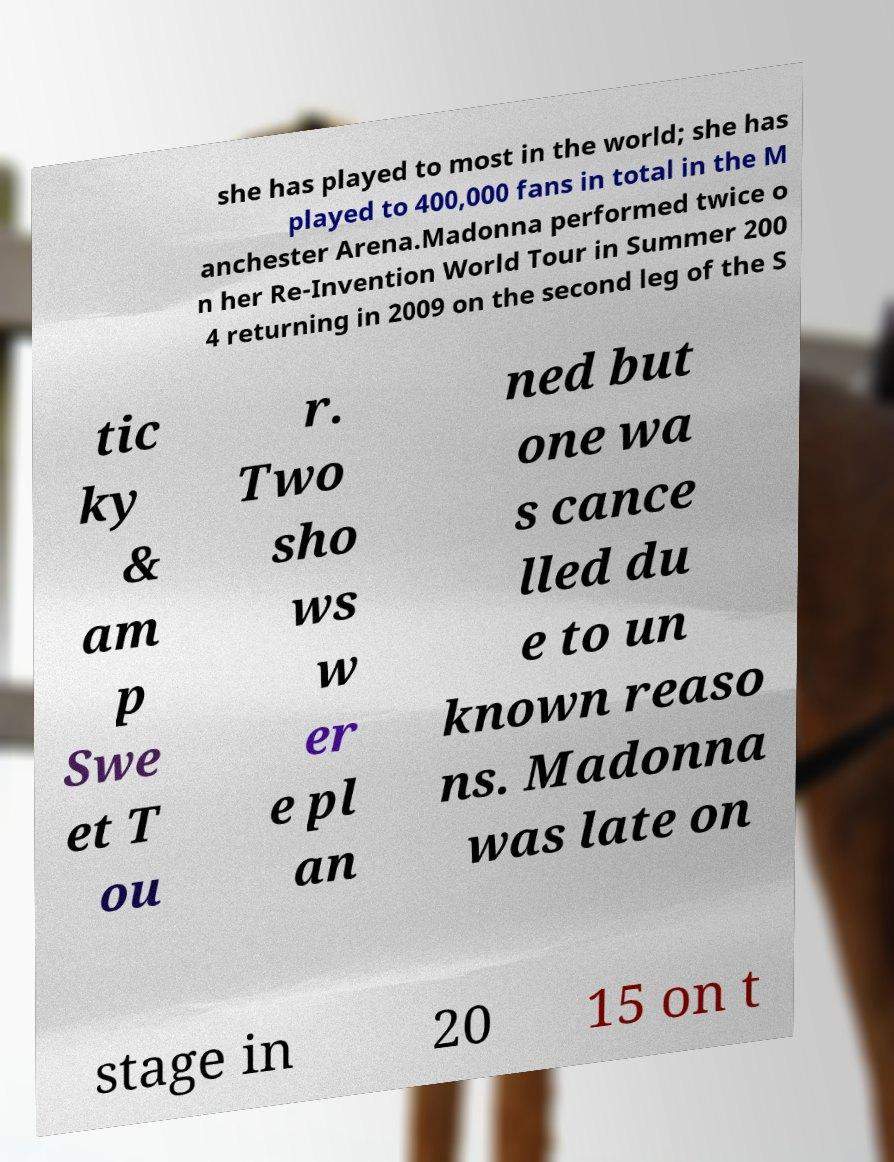Could you extract and type out the text from this image? she has played to most in the world; she has played to 400,000 fans in total in the M anchester Arena.Madonna performed twice o n her Re-Invention World Tour in Summer 200 4 returning in 2009 on the second leg of the S tic ky & am p Swe et T ou r. Two sho ws w er e pl an ned but one wa s cance lled du e to un known reaso ns. Madonna was late on stage in 20 15 on t 